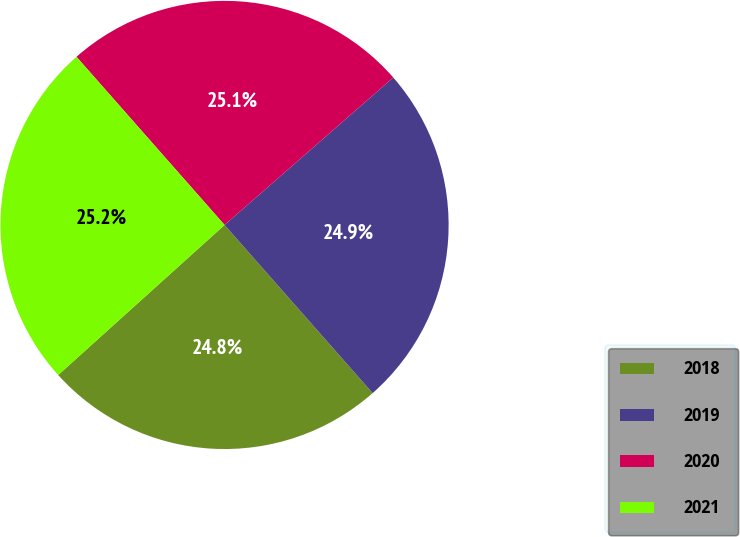<chart> <loc_0><loc_0><loc_500><loc_500><pie_chart><fcel>2018<fcel>2019<fcel>2020<fcel>2021<nl><fcel>24.81%<fcel>24.94%<fcel>25.06%<fcel>25.19%<nl></chart> 